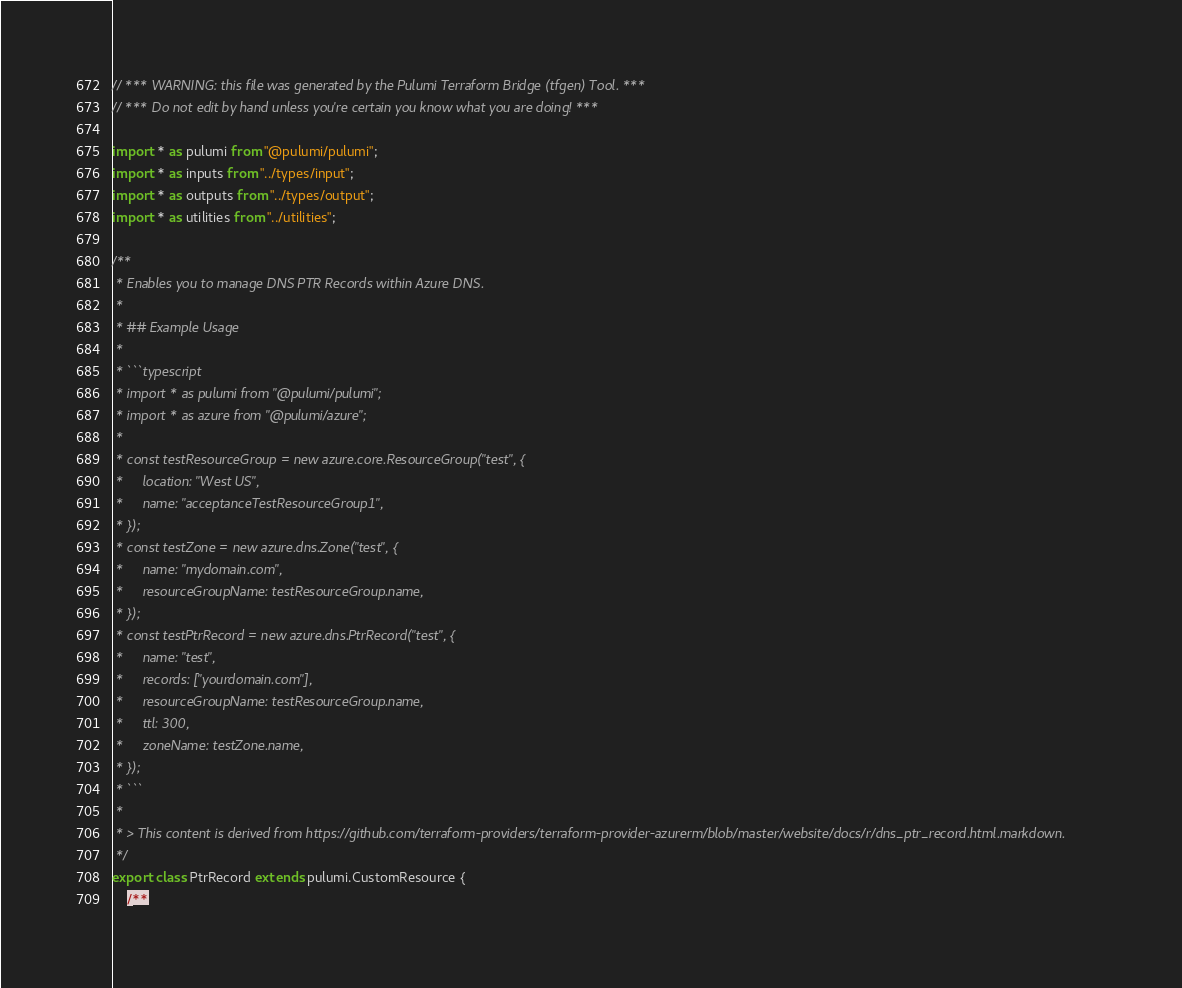<code> <loc_0><loc_0><loc_500><loc_500><_TypeScript_>// *** WARNING: this file was generated by the Pulumi Terraform Bridge (tfgen) Tool. ***
// *** Do not edit by hand unless you're certain you know what you are doing! ***

import * as pulumi from "@pulumi/pulumi";
import * as inputs from "../types/input";
import * as outputs from "../types/output";
import * as utilities from "../utilities";

/**
 * Enables you to manage DNS PTR Records within Azure DNS.
 * 
 * ## Example Usage
 * 
 * ```typescript
 * import * as pulumi from "@pulumi/pulumi";
 * import * as azure from "@pulumi/azure";
 * 
 * const testResourceGroup = new azure.core.ResourceGroup("test", {
 *     location: "West US",
 *     name: "acceptanceTestResourceGroup1",
 * });
 * const testZone = new azure.dns.Zone("test", {
 *     name: "mydomain.com",
 *     resourceGroupName: testResourceGroup.name,
 * });
 * const testPtrRecord = new azure.dns.PtrRecord("test", {
 *     name: "test",
 *     records: ["yourdomain.com"],
 *     resourceGroupName: testResourceGroup.name,
 *     ttl: 300,
 *     zoneName: testZone.name,
 * });
 * ```
 *
 * > This content is derived from https://github.com/terraform-providers/terraform-provider-azurerm/blob/master/website/docs/r/dns_ptr_record.html.markdown.
 */
export class PtrRecord extends pulumi.CustomResource {
    /**</code> 